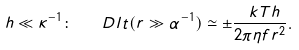<formula> <loc_0><loc_0><loc_500><loc_500>h \ll \kappa ^ { - 1 } \colon \quad D l t ( r \gg \alpha ^ { - 1 } ) \simeq \pm \frac { \ k T h } { 2 \pi \eta f r ^ { 2 } } .</formula> 